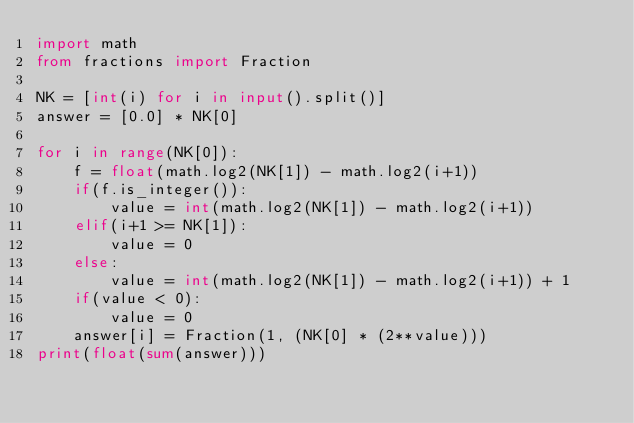<code> <loc_0><loc_0><loc_500><loc_500><_Python_>import math
from fractions import Fraction

NK = [int(i) for i in input().split()]
answer = [0.0] * NK[0]

for i in range(NK[0]):
    f = float(math.log2(NK[1]) - math.log2(i+1))
    if(f.is_integer()):
        value = int(math.log2(NK[1]) - math.log2(i+1))
    elif(i+1 >= NK[1]):
        value = 0
    else:
        value = int(math.log2(NK[1]) - math.log2(i+1)) + 1
    if(value < 0):
        value = 0
    answer[i] = Fraction(1, (NK[0] * (2**value)))
print(float(sum(answer)))</code> 